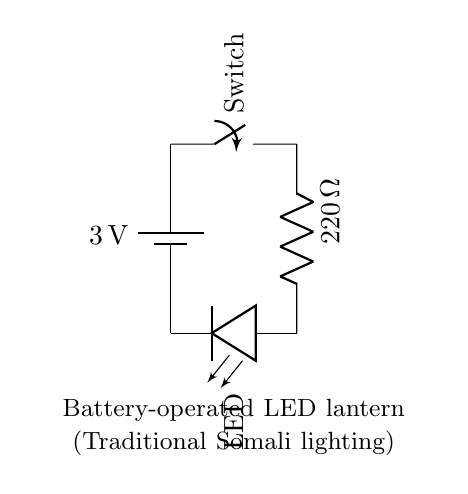What is the voltage of the battery in this circuit? The voltage is indicated on the battery component of the circuit and is stated as 3V. This is the potential difference provided by the battery to power the circuit.
Answer: 3V What is the resistance value of the resistor in this circuit? The resistance value is labeled on the resistor component of the circuit as 220 ohms. This specifies how much the resistor opposes the flow of electric current.
Answer: 220 ohm What does the switch do in this circuit? The switch allows the circuit to be either closed or open. When the switch is closed, electric current flows to power the LED; when it is open, the current stops, turning off the LED.
Answer: Control current What is the role of the LED in this circuit? The LED, or Light Emitting Diode, emits light when current flows through it. It lights up as long as the circuit is closed and there is sufficient current, serving as the light source for the lantern.
Answer: Emit light Is this circuit a series circuit or a parallel circuit? The connections in the circuit show that all components are connected one after another in a single path, which defines it as a series circuit. This means that the same current flows through all components sequentially.
Answer: Series circuit What would happen if the switch is opened? Opening the switch breaks the circuit, interrupting the flow of current. As a result, the LED will turn off because no electricity can reach it.
Answer: LED turns off 